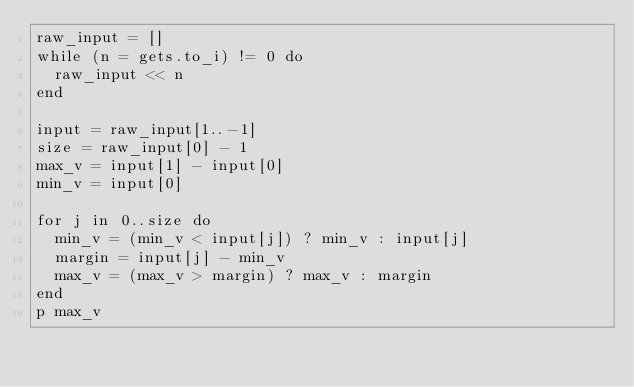<code> <loc_0><loc_0><loc_500><loc_500><_Ruby_>raw_input = []
while (n = gets.to_i) != 0 do
  raw_input << n
end

input = raw_input[1..-1]
size = raw_input[0] - 1
max_v = input[1] - input[0]
min_v = input[0]

for j in 0..size do
  min_v = (min_v < input[j]) ? min_v : input[j]
  margin = input[j] - min_v
  max_v = (max_v > margin) ? max_v : margin
end
p max_v

</code> 